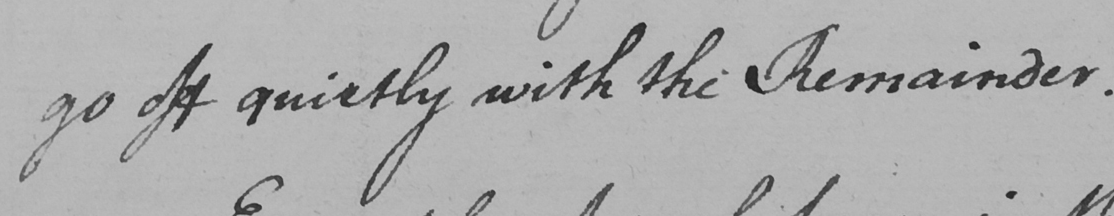What is written in this line of handwriting? go off quietly with the Remainder . 